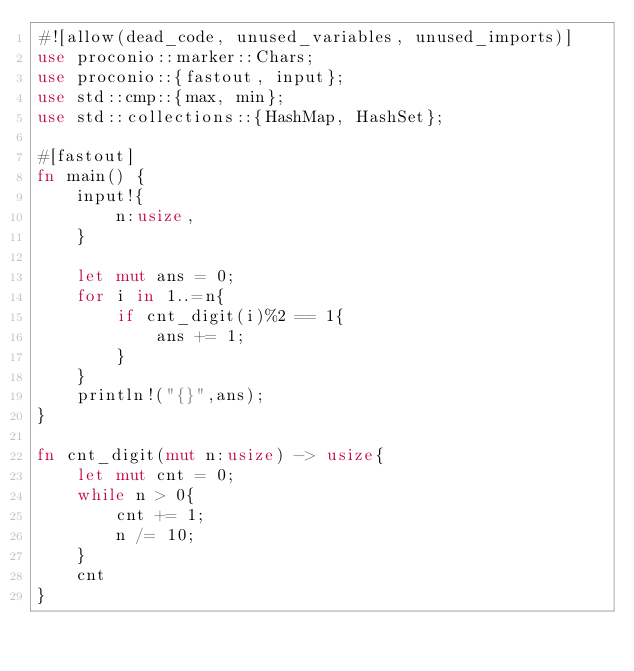<code> <loc_0><loc_0><loc_500><loc_500><_Rust_>#![allow(dead_code, unused_variables, unused_imports)]
use proconio::marker::Chars;
use proconio::{fastout, input};
use std::cmp::{max, min};
use std::collections::{HashMap, HashSet};

#[fastout]
fn main() {
    input!{
        n:usize,
    }
    
    let mut ans = 0;
    for i in 1..=n{
        if cnt_digit(i)%2 == 1{
            ans += 1;
        }
    }
    println!("{}",ans);
}   

fn cnt_digit(mut n:usize) -> usize{
    let mut cnt = 0;
    while n > 0{
        cnt += 1;
        n /= 10;
    }
    cnt
}</code> 